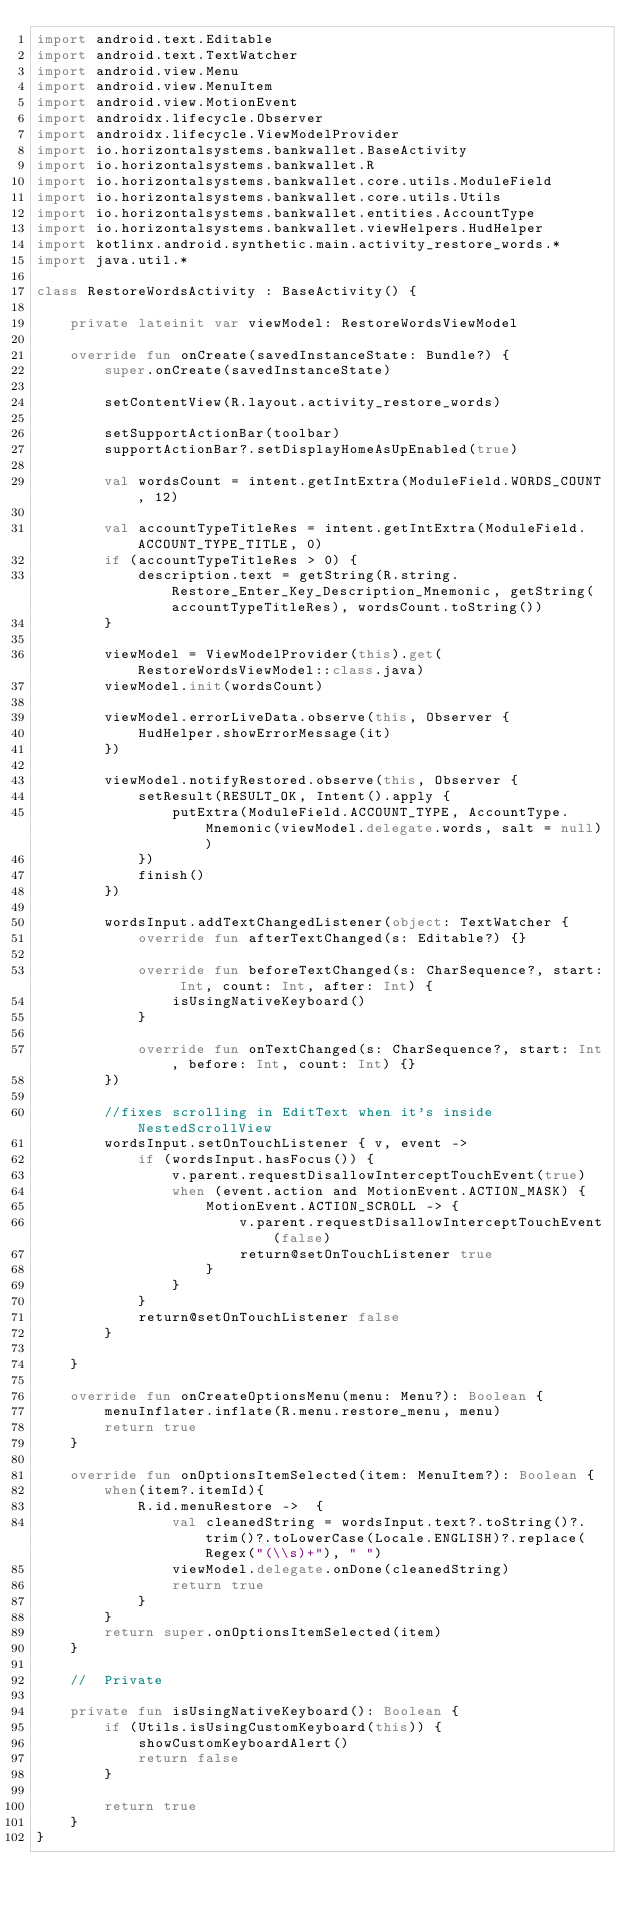<code> <loc_0><loc_0><loc_500><loc_500><_Kotlin_>import android.text.Editable
import android.text.TextWatcher
import android.view.Menu
import android.view.MenuItem
import android.view.MotionEvent
import androidx.lifecycle.Observer
import androidx.lifecycle.ViewModelProvider
import io.horizontalsystems.bankwallet.BaseActivity
import io.horizontalsystems.bankwallet.R
import io.horizontalsystems.bankwallet.core.utils.ModuleField
import io.horizontalsystems.bankwallet.core.utils.Utils
import io.horizontalsystems.bankwallet.entities.AccountType
import io.horizontalsystems.bankwallet.viewHelpers.HudHelper
import kotlinx.android.synthetic.main.activity_restore_words.*
import java.util.*

class RestoreWordsActivity : BaseActivity() {

    private lateinit var viewModel: RestoreWordsViewModel

    override fun onCreate(savedInstanceState: Bundle?) {
        super.onCreate(savedInstanceState)

        setContentView(R.layout.activity_restore_words)

        setSupportActionBar(toolbar)
        supportActionBar?.setDisplayHomeAsUpEnabled(true)

        val wordsCount = intent.getIntExtra(ModuleField.WORDS_COUNT, 12)

        val accountTypeTitleRes = intent.getIntExtra(ModuleField.ACCOUNT_TYPE_TITLE, 0)
        if (accountTypeTitleRes > 0) {
            description.text = getString(R.string.Restore_Enter_Key_Description_Mnemonic, getString(accountTypeTitleRes), wordsCount.toString())
        }

        viewModel = ViewModelProvider(this).get(RestoreWordsViewModel::class.java)
        viewModel.init(wordsCount)

        viewModel.errorLiveData.observe(this, Observer {
            HudHelper.showErrorMessage(it)
        })

        viewModel.notifyRestored.observe(this, Observer {
            setResult(RESULT_OK, Intent().apply {
                putExtra(ModuleField.ACCOUNT_TYPE, AccountType.Mnemonic(viewModel.delegate.words, salt = null))
            })
            finish()
        })

        wordsInput.addTextChangedListener(object: TextWatcher {
            override fun afterTextChanged(s: Editable?) {}

            override fun beforeTextChanged(s: CharSequence?, start: Int, count: Int, after: Int) {
                isUsingNativeKeyboard()
            }

            override fun onTextChanged(s: CharSequence?, start: Int, before: Int, count: Int) {}
        })

        //fixes scrolling in EditText when it's inside NestedScrollView
        wordsInput.setOnTouchListener { v, event ->
            if (wordsInput.hasFocus()) {
                v.parent.requestDisallowInterceptTouchEvent(true)
                when (event.action and MotionEvent.ACTION_MASK) {
                    MotionEvent.ACTION_SCROLL -> {
                        v.parent.requestDisallowInterceptTouchEvent(false)
                        return@setOnTouchListener true
                    }
                }
            }
            return@setOnTouchListener false
        }

    }

    override fun onCreateOptionsMenu(menu: Menu?): Boolean {
        menuInflater.inflate(R.menu.restore_menu, menu)
        return true
    }

    override fun onOptionsItemSelected(item: MenuItem?): Boolean {
        when(item?.itemId){
            R.id.menuRestore ->  {
                val cleanedString = wordsInput.text?.toString()?.trim()?.toLowerCase(Locale.ENGLISH)?.replace(Regex("(\\s)+"), " ")
                viewModel.delegate.onDone(cleanedString)
                return true
            }
        }
        return super.onOptionsItemSelected(item)
    }

    //  Private

    private fun isUsingNativeKeyboard(): Boolean {
        if (Utils.isUsingCustomKeyboard(this)) {
            showCustomKeyboardAlert()
            return false
        }

        return true
    }
}
</code> 